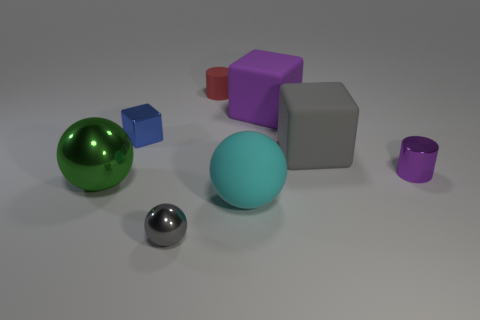Subtract all green spheres. How many spheres are left? 2 Subtract all small blue cubes. How many cubes are left? 2 Subtract all spheres. How many objects are left? 5 Subtract 1 blocks. How many blocks are left? 2 Add 7 red matte cylinders. How many red matte cylinders are left? 8 Add 4 tiny gray shiny things. How many tiny gray shiny things exist? 5 Add 2 tiny purple balls. How many objects exist? 10 Subtract 0 red cubes. How many objects are left? 8 Subtract all gray cylinders. Subtract all green spheres. How many cylinders are left? 2 Subtract all red spheres. How many red cylinders are left? 1 